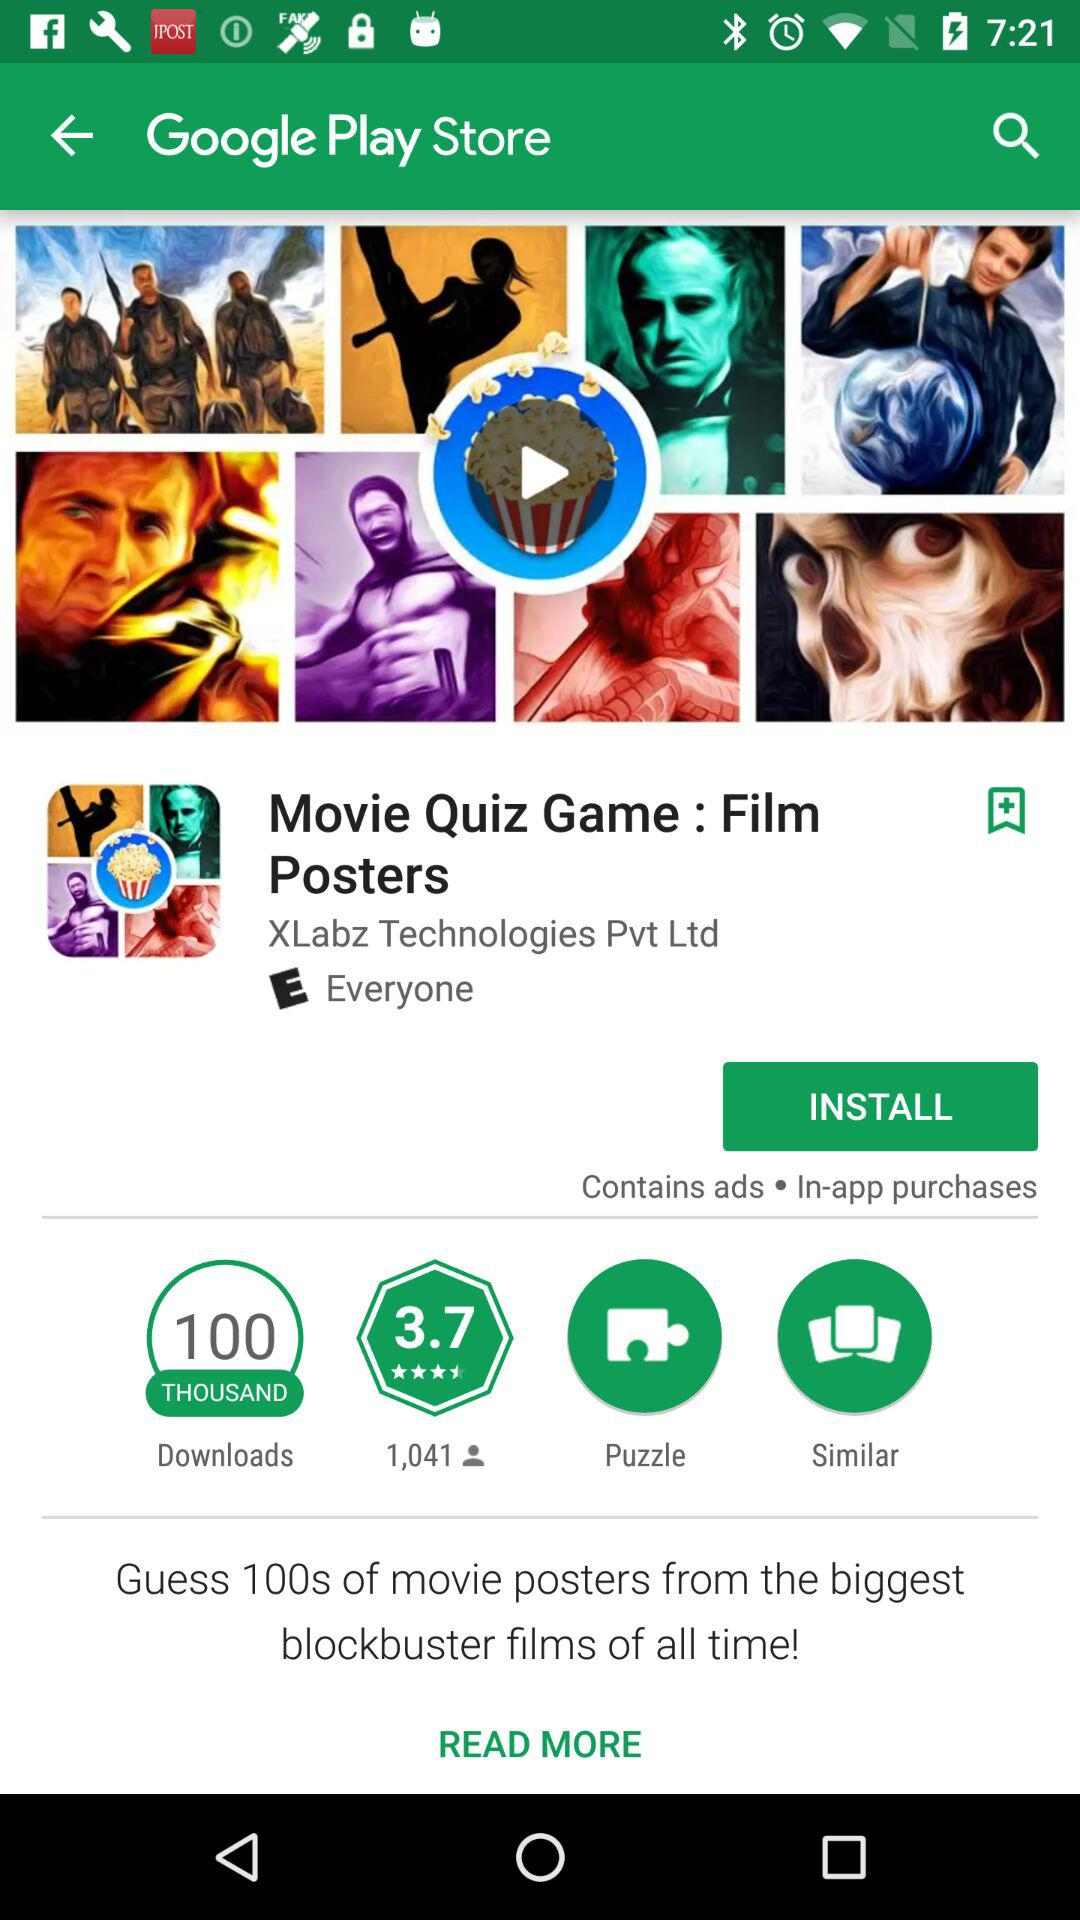How many people have rated the application? The application has been rated by 1,041 people. 